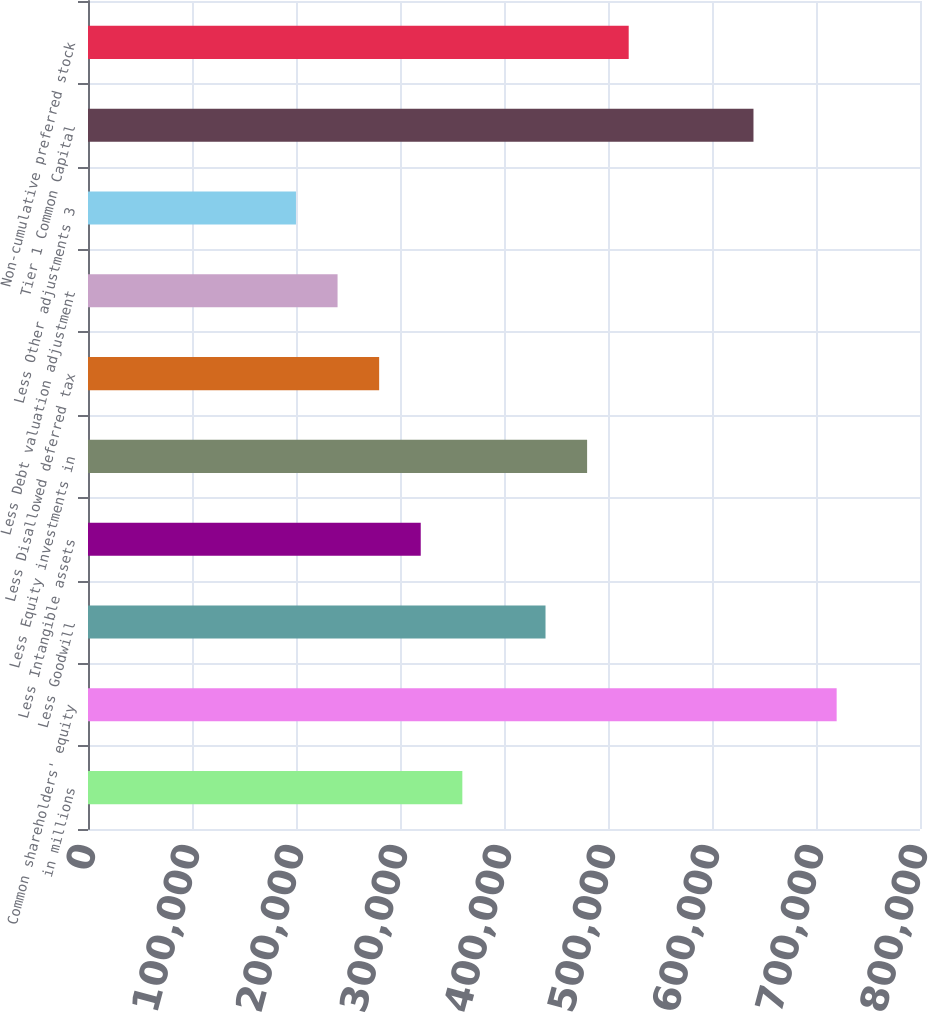Convert chart to OTSL. <chart><loc_0><loc_0><loc_500><loc_500><bar_chart><fcel>in millions<fcel>Common shareholders' equity<fcel>Less Goodwill<fcel>Less Intangible assets<fcel>Less Equity investments in<fcel>Less Disallowed deferred tax<fcel>Less Debt valuation adjustment<fcel>Less Other adjustments 3<fcel>Tier 1 Common Capital<fcel>Non-cumulative preferred stock<nl><fcel>359936<fcel>719865<fcel>439920<fcel>319944<fcel>479912<fcel>279952<fcel>239960<fcel>199968<fcel>639880<fcel>519904<nl></chart> 